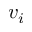<formula> <loc_0><loc_0><loc_500><loc_500>v _ { i }</formula> 